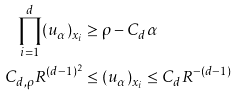Convert formula to latex. <formula><loc_0><loc_0><loc_500><loc_500>\prod _ { i = 1 } ^ { d } ( u _ { \alpha } ) _ { x _ { i } } & \geq \rho - C _ { d } \alpha \\ C _ { d , \rho } R ^ { ( d - 1 ) ^ { 2 } } & \leq ( u _ { \alpha } ) _ { x _ { i } } \leq C _ { d } R ^ { - ( d - 1 ) }</formula> 